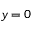Convert formula to latex. <formula><loc_0><loc_0><loc_500><loc_500>y = 0</formula> 